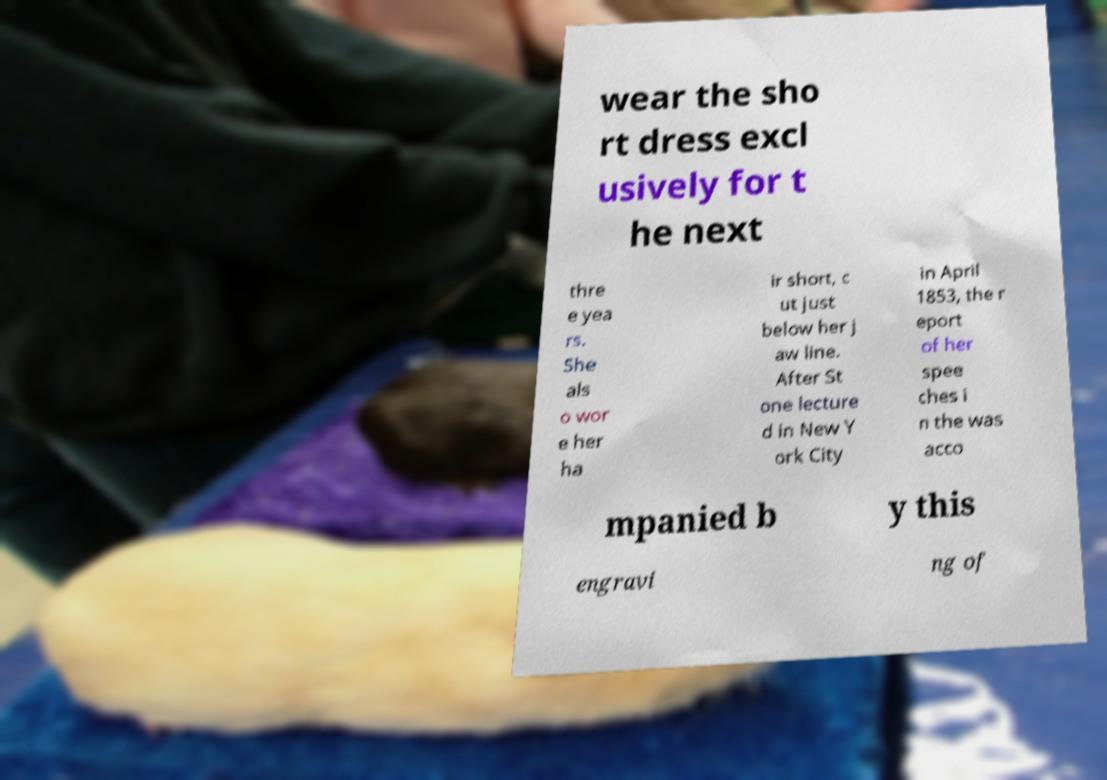There's text embedded in this image that I need extracted. Can you transcribe it verbatim? wear the sho rt dress excl usively for t he next thre e yea rs. She als o wor e her ha ir short, c ut just below her j aw line. After St one lecture d in New Y ork City in April 1853, the r eport of her spee ches i n the was acco mpanied b y this engravi ng of 